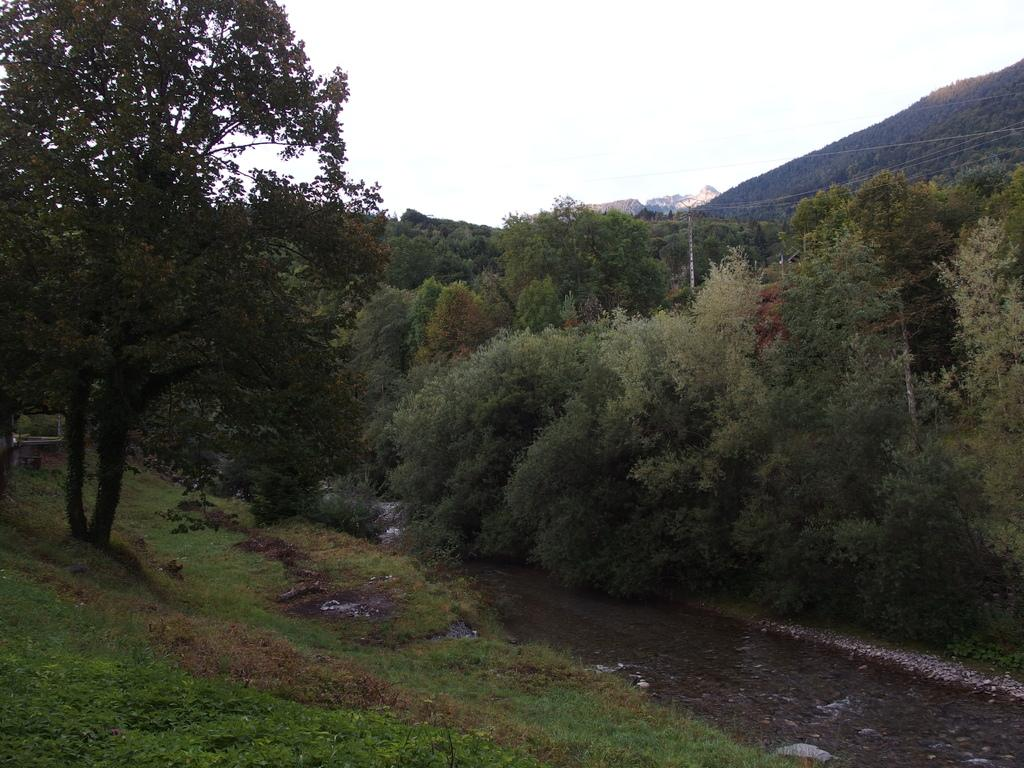What type of natural landscape is depicted in the image? The image features mountains, trees, and a lake. How do the trees and the lake interact in the image? The lake flows through the trees in the image. What is visible at the top of the image? The sky is visible at the top of the image. Can you tell me how many farmers are present in the image? There are no farmers present in the image; it features a natural landscape with mountains, trees, and a lake. What type of dog can be seen playing near the lake in the image? There is no dog present in the image; it only features a natural landscape with mountains, trees, and a lake. 